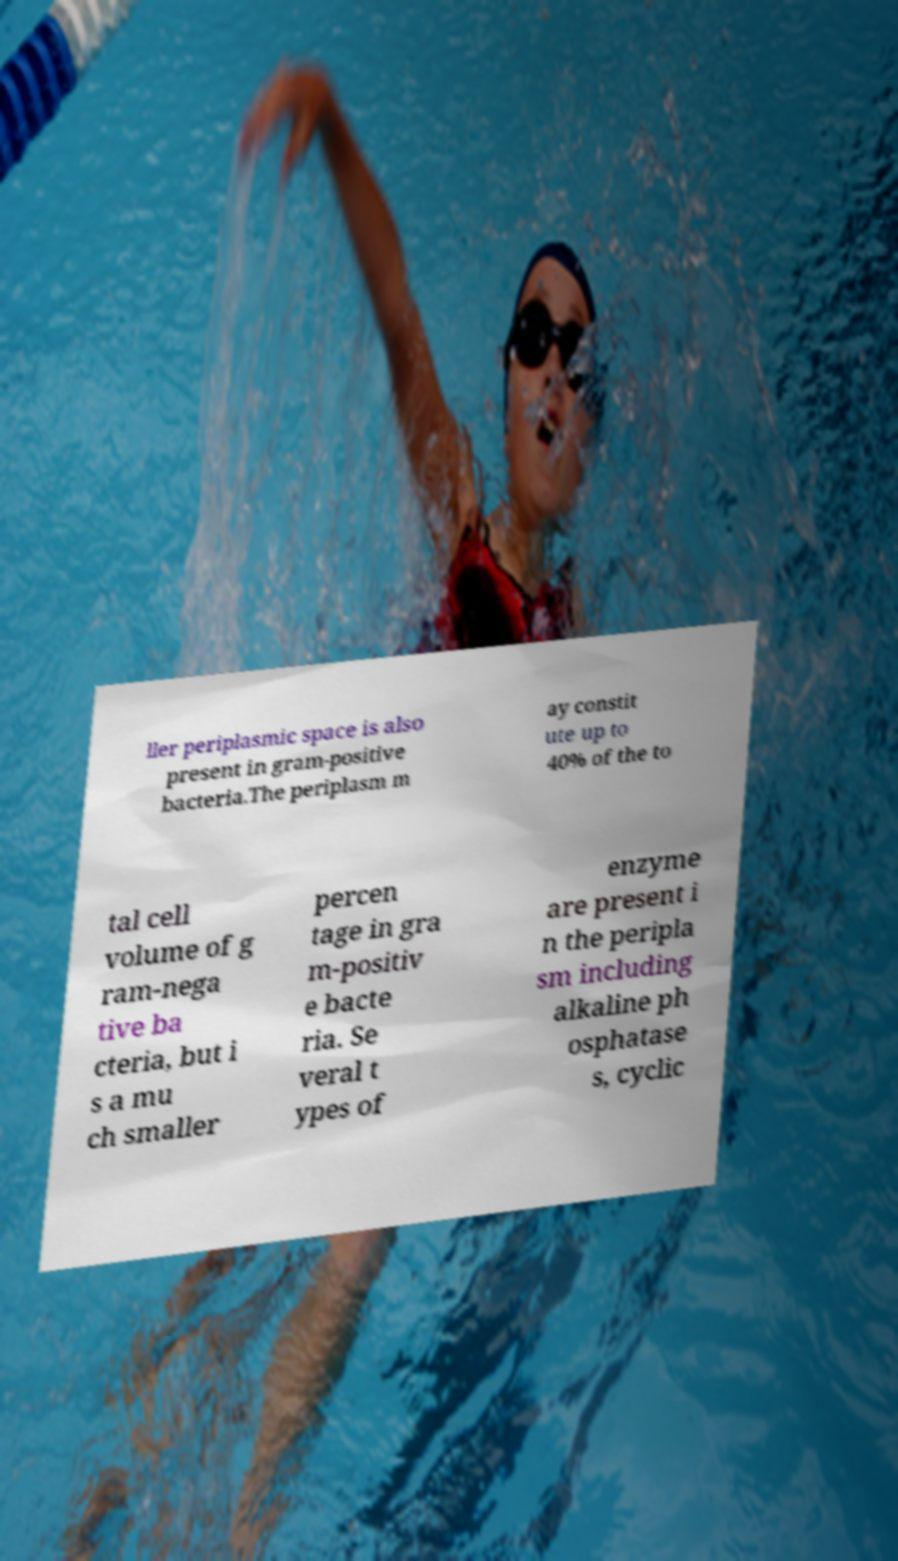Can you read and provide the text displayed in the image?This photo seems to have some interesting text. Can you extract and type it out for me? ller periplasmic space is also present in gram-positive bacteria.The periplasm m ay constit ute up to 40% of the to tal cell volume of g ram-nega tive ba cteria, but i s a mu ch smaller percen tage in gra m-positiv e bacte ria. Se veral t ypes of enzyme are present i n the peripla sm including alkaline ph osphatase s, cyclic 